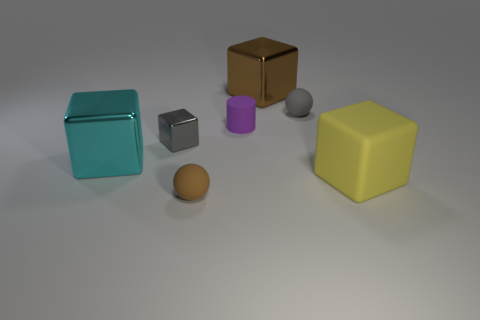Add 2 matte cylinders. How many objects exist? 9 Subtract all big cyan blocks. How many blocks are left? 3 Subtract 1 cylinders. How many cylinders are left? 0 Subtract all brown blocks. Subtract all purple spheres. How many blocks are left? 3 Subtract all cyan spheres. How many yellow cubes are left? 1 Subtract all big red spheres. Subtract all tiny rubber objects. How many objects are left? 4 Add 2 small gray matte balls. How many small gray matte balls are left? 3 Add 1 tiny blocks. How many tiny blocks exist? 2 Subtract all brown blocks. How many blocks are left? 3 Subtract 0 purple cubes. How many objects are left? 7 